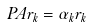<formula> <loc_0><loc_0><loc_500><loc_500>P A r _ { k } = \alpha _ { k } r _ { k }</formula> 